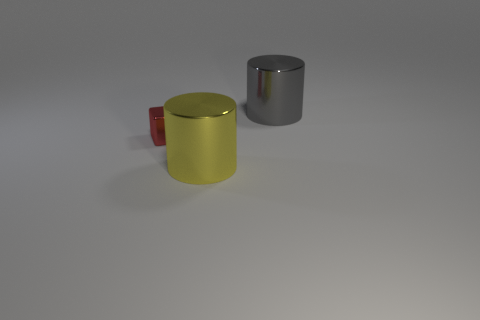What could be the possible use of these objects? The objects could serve a variety of purposes. The cylinders might be containers or parts of a larger mechanism, while the red block could be a simple toy, a paperweight, or a decorative element. Their uses are not discernible from the image alone and could be entirely contextual. 